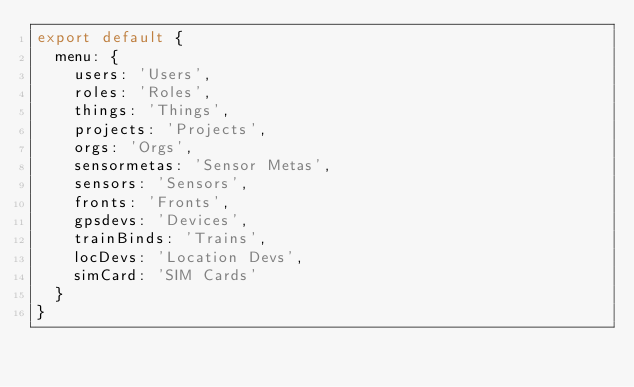<code> <loc_0><loc_0><loc_500><loc_500><_JavaScript_>export default {
  menu: {
    users: 'Users',
    roles: 'Roles',
    things: 'Things',
    projects: 'Projects',
    orgs: 'Orgs',
    sensormetas: 'Sensor Metas',
    sensors: 'Sensors',
    fronts: 'Fronts',
    gpsdevs: 'Devices',
    trainBinds: 'Trains',
    locDevs: 'Location Devs',
    simCard: 'SIM Cards'
  }
}
</code> 